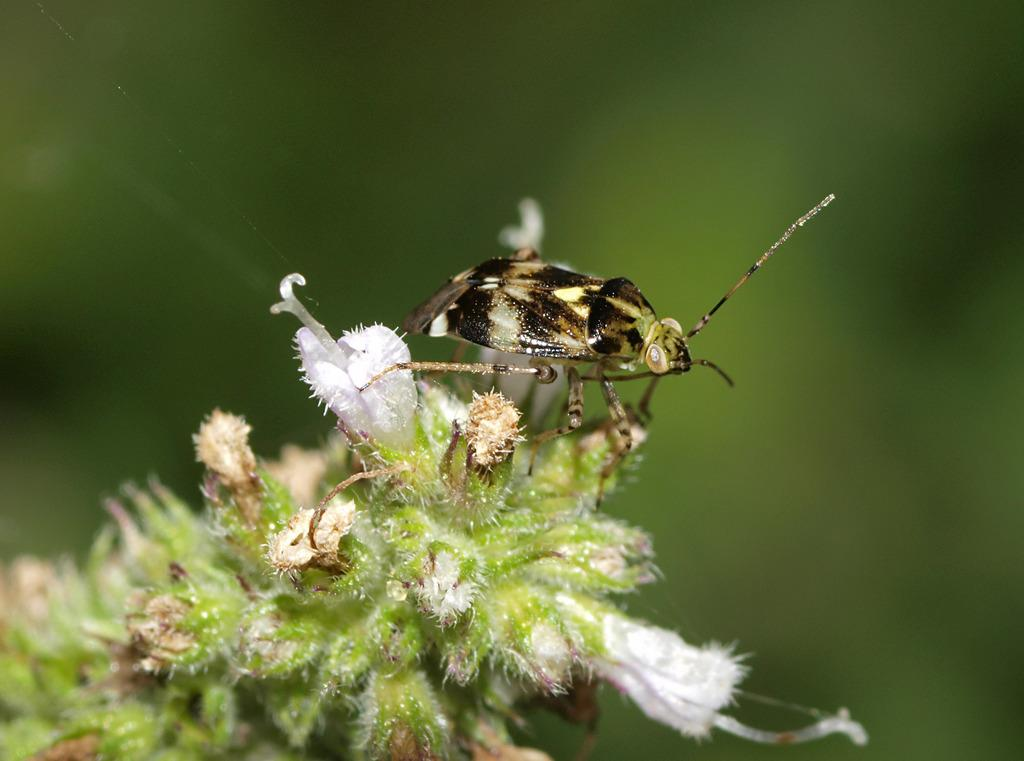What is the main subject in the foreground of the image? There is an insect in the foreground of the image. What is the insect doing or interacting with in the image? The insect is on flowers. What can be seen in the image that is related to the flowers? The plant of the flowers is visible. How would you describe the background of the image? The background of the image is blurred. What type of pancake is being served at the business meeting in the image? There is no pancake or business meeting present in the image; it features an insect on flowers with a blurred background. 